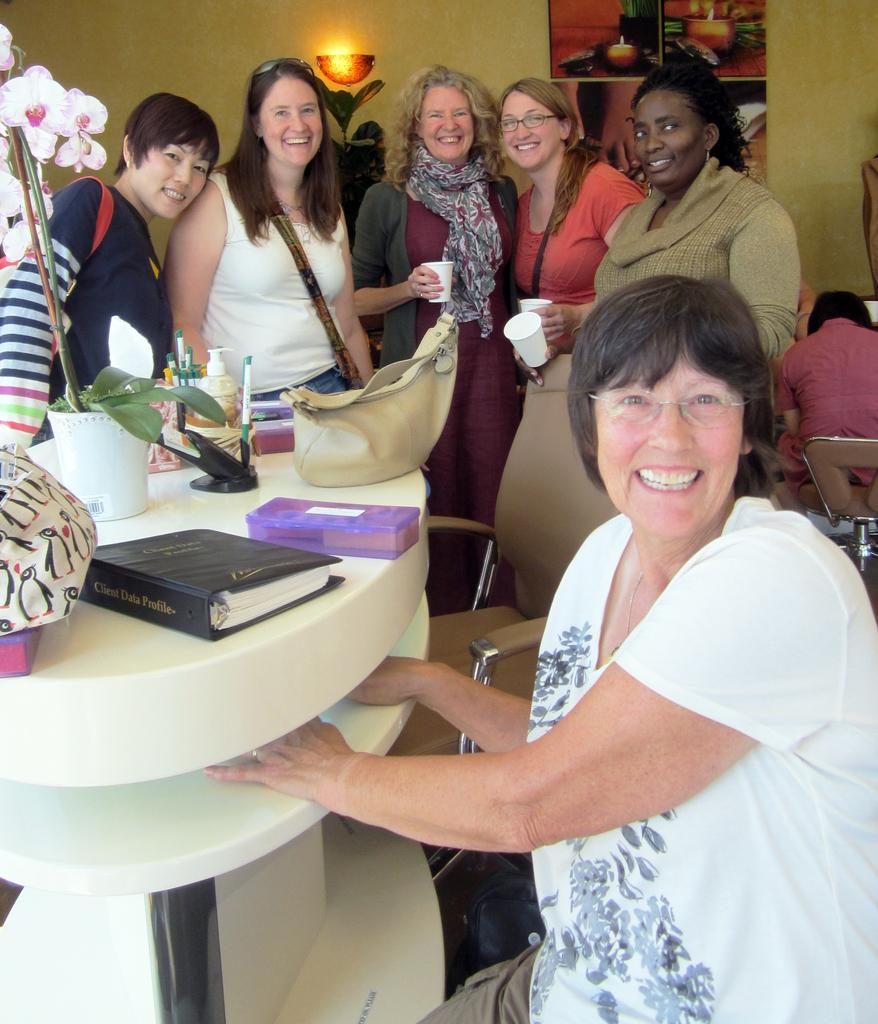Is the lady in the foreground wearing glasses?
Give a very brief answer. Answering does not require reading text in the image. What is the title of the book?
Your response must be concise. Client data profile. 